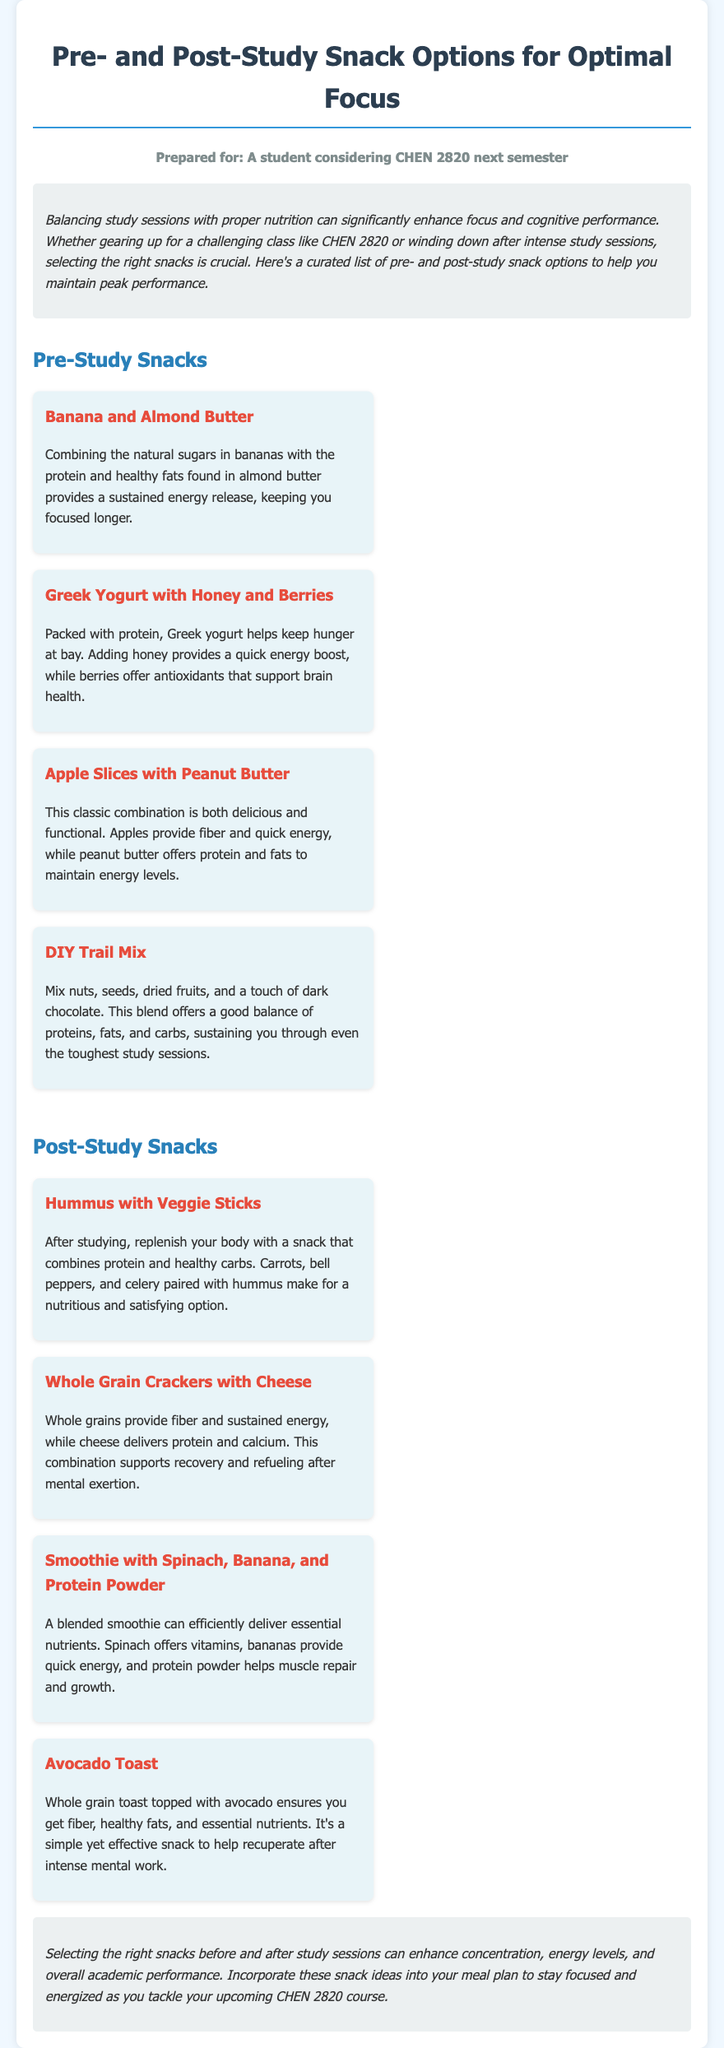What is the title of the document? The title is presented in a prominent header format at the top of the document.
Answer: Pre- and Post-Study Snack Options for Optimal Focus Who is the document prepared for? This information is stated at the beginning of the document, indicating the target audience.
Answer: A student considering CHEN 2820 next semester Name one pre-study snack option. The document lists multiple pre-study snack options under the relevant section, one of which can be selected as an example.
Answer: Banana and Almond Butter What type of food is suggested as a post-study snack that includes veggies? The post-study snack section provides various options combining different food groups, including one specifically mentioned with vegetables.
Answer: Hummus with Veggie Sticks How many pre-study snack options are listed? The document distinctly categorizes snacks, allowing for an easy count within the pre-study section.
Answer: Four Which snack option includes a fruit with high protein? The snacks listed provide various combinations, and the question looks for a specific pairing that meets these criteria.
Answer: Greek Yogurt with Honey and Berries What food combination is recommended for muscle repair and growth? The document cites a specific post-study snack that focuses on delivering essential nutrients for muscle recovery.
Answer: Smoothie with Spinach, Banana, and Protein Powder What is the main benefit of the DIY Trail Mix? The document mentions the nutritional contributions of this snack during the study session.
Answer: Sustaining energy through proteins, fats, and carbs What does avocado toast provide as nutrients? The document describes the nutritional benefits of this specific snack after mental work.
Answer: Fiber, healthy fats, and essential nutrients 